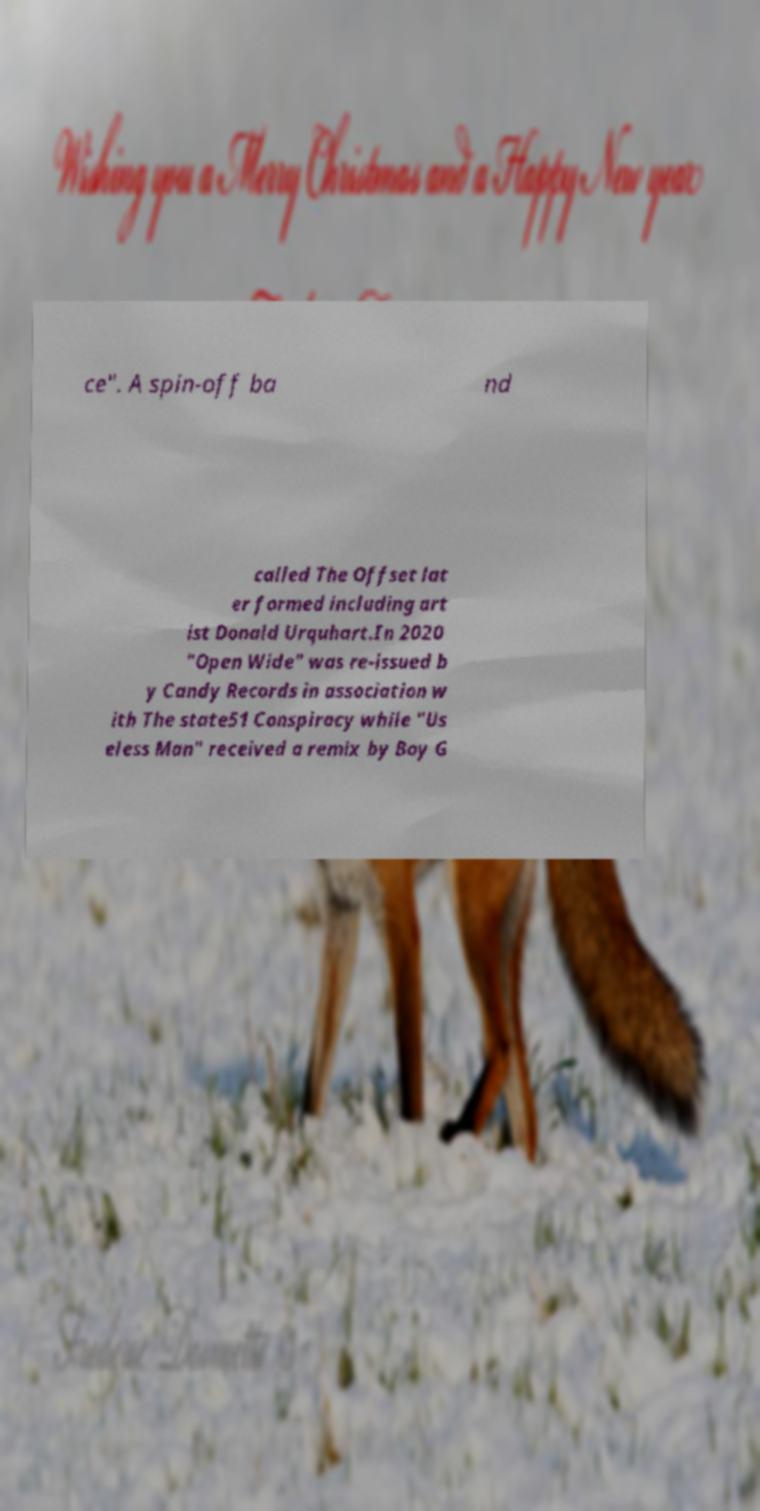Please read and relay the text visible in this image. What does it say? ce". A spin-off ba nd called The Offset lat er formed including art ist Donald Urquhart.In 2020 "Open Wide" was re-issued b y Candy Records in association w ith The state51 Conspiracy while "Us eless Man" received a remix by Boy G 